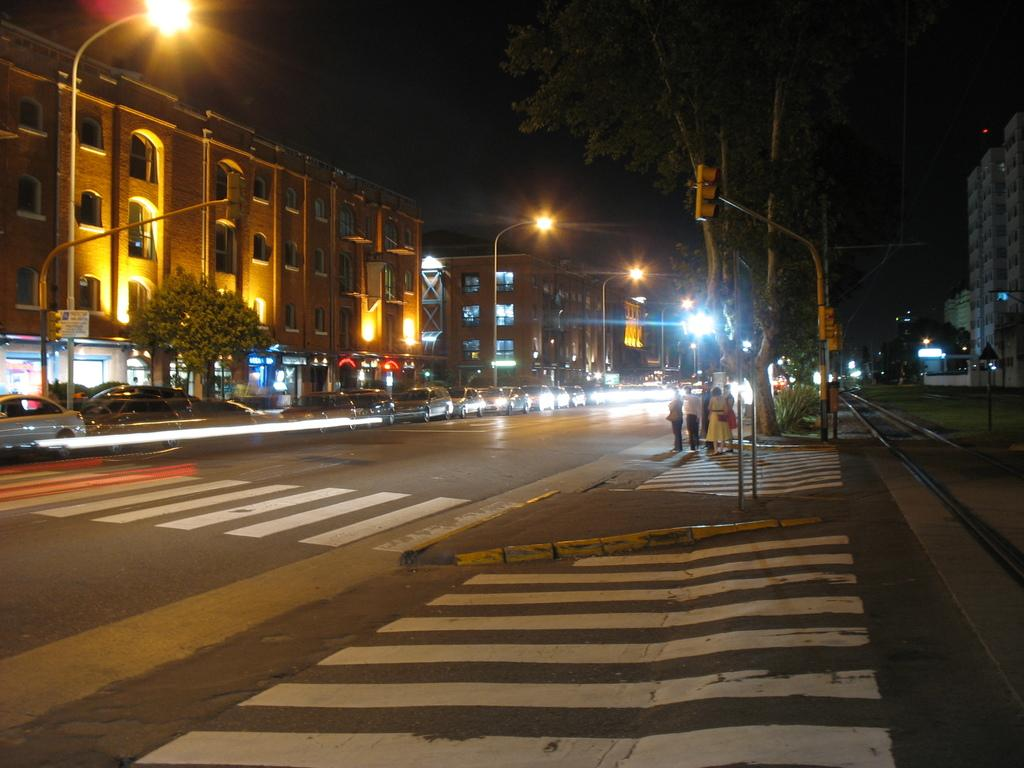What can be seen on the road in the image? There are vehicles on the road in the image. What type of natural elements are visible in the image? There are trees visible in the image. What type of structures can be seen in the image? There are buildings in the image. Who or what is present in the image? There are people in the image. What type of traffic control device is present in the image? There is a traffic light pole in the image. What type of lighting infrastructure is present in the image? There are light poles in the image. How many trains are visible in the image? There are no trains visible in the image. Can you help me find the number of helpers in the image? There is no mention of helpers or a number associated with them in the image. 